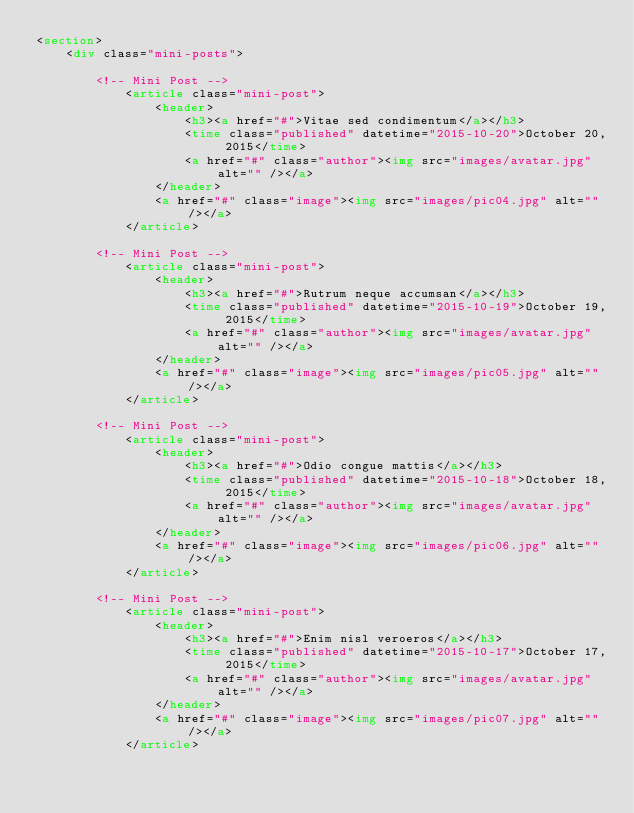Convert code to text. <code><loc_0><loc_0><loc_500><loc_500><_HTML_><section>
    <div class="mini-posts">

        <!-- Mini Post -->
            <article class="mini-post">
                <header>
                    <h3><a href="#">Vitae sed condimentum</a></h3>
                    <time class="published" datetime="2015-10-20">October 20, 2015</time>
                    <a href="#" class="author"><img src="images/avatar.jpg" alt="" /></a>
                </header>
                <a href="#" class="image"><img src="images/pic04.jpg" alt="" /></a>
            </article>

        <!-- Mini Post -->
            <article class="mini-post">
                <header>
                    <h3><a href="#">Rutrum neque accumsan</a></h3>
                    <time class="published" datetime="2015-10-19">October 19, 2015</time>
                    <a href="#" class="author"><img src="images/avatar.jpg" alt="" /></a>
                </header>
                <a href="#" class="image"><img src="images/pic05.jpg" alt="" /></a>
            </article>

        <!-- Mini Post -->
            <article class="mini-post">
                <header>
                    <h3><a href="#">Odio congue mattis</a></h3>
                    <time class="published" datetime="2015-10-18">October 18, 2015</time>
                    <a href="#" class="author"><img src="images/avatar.jpg" alt="" /></a>
                </header>
                <a href="#" class="image"><img src="images/pic06.jpg" alt="" /></a>
            </article>

        <!-- Mini Post -->
            <article class="mini-post">
                <header>
                    <h3><a href="#">Enim nisl veroeros</a></h3>
                    <time class="published" datetime="2015-10-17">October 17, 2015</time>
                    <a href="#" class="author"><img src="images/avatar.jpg" alt="" /></a>
                </header>
                <a href="#" class="image"><img src="images/pic07.jpg" alt="" /></a>
            </article>
</code> 